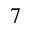<formula> <loc_0><loc_0><loc_500><loc_500>7</formula> 